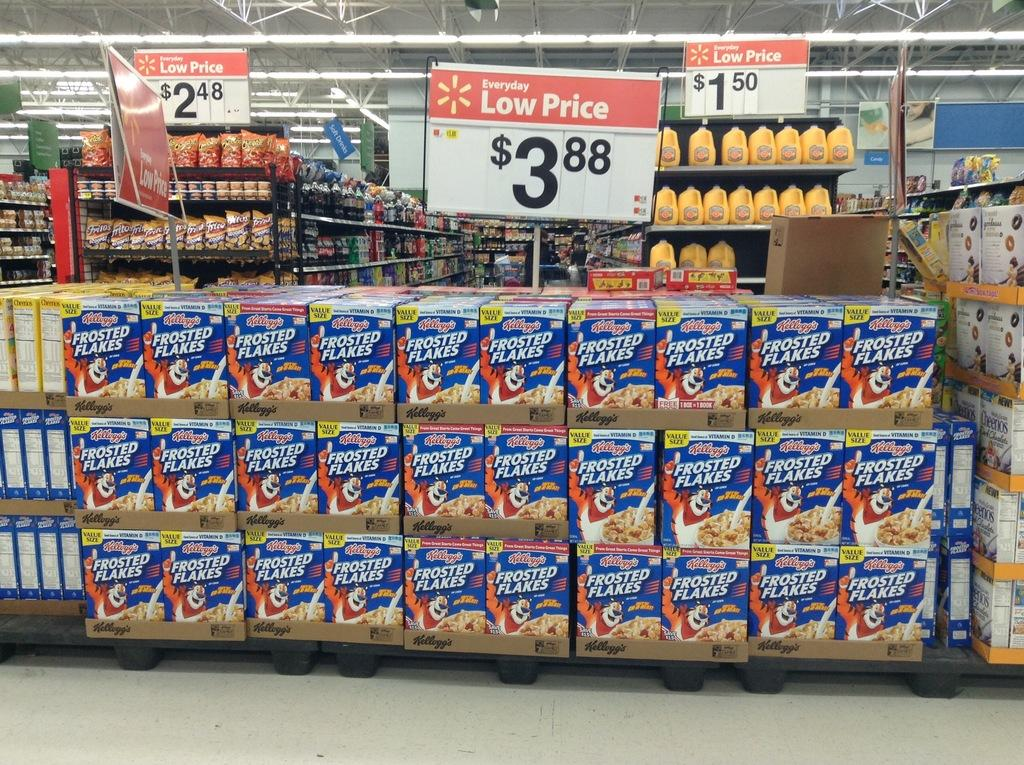<image>
Write a terse but informative summary of the picture. Man Frosted Flakes on display under a price sign that says $3.88 